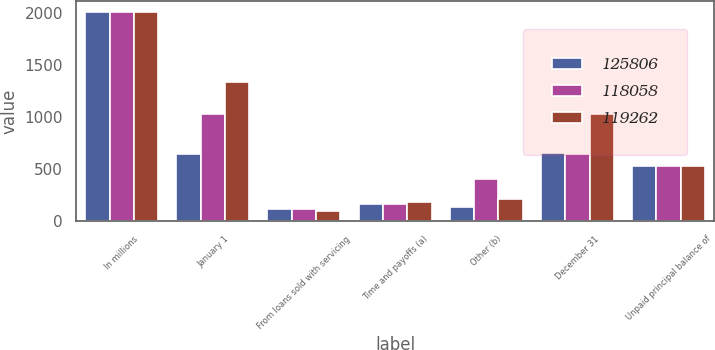<chart> <loc_0><loc_0><loc_500><loc_500><stacked_bar_chart><ecel><fcel>In millions<fcel>January 1<fcel>From loans sold with servicing<fcel>Time and payoffs (a)<fcel>Other (b)<fcel>December 31<fcel>Unpaid principal balance of<nl><fcel>125806<fcel>2012<fcel>647<fcel>117<fcel>167<fcel>138<fcel>650<fcel>526.5<nl><fcel>118058<fcel>2011<fcel>1033<fcel>118<fcel>163<fcel>406<fcel>647<fcel>526.5<nl><fcel>119262<fcel>2010<fcel>1332<fcel>95<fcel>185<fcel>209<fcel>1033<fcel>526.5<nl></chart> 